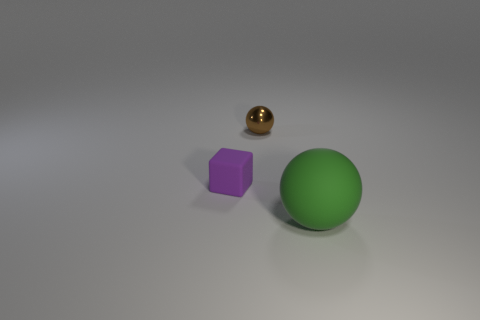Add 3 cyan matte things. How many objects exist? 6 Subtract all brown spheres. How many spheres are left? 1 Subtract all spheres. How many objects are left? 1 Subtract 1 spheres. How many spheres are left? 1 Subtract all purple rubber cubes. Subtract all big cyan matte cylinders. How many objects are left? 2 Add 3 small purple matte things. How many small purple matte things are left? 4 Add 2 purple rubber blocks. How many purple rubber blocks exist? 3 Subtract 0 yellow cubes. How many objects are left? 3 Subtract all gray blocks. Subtract all green balls. How many blocks are left? 1 